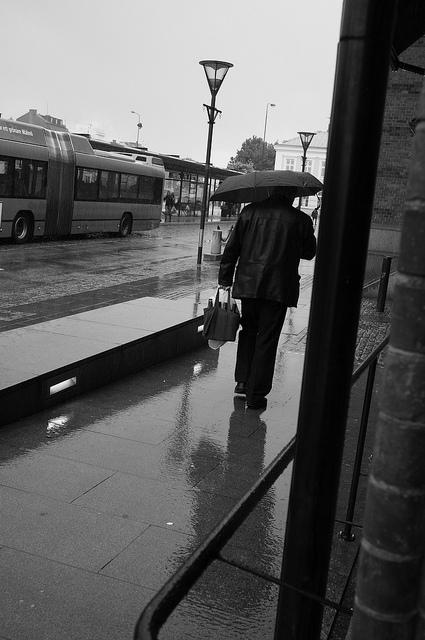How many people are in the street?
Quick response, please. 1. What is the weather like?
Quick response, please. Rainy. Could that be a bus stop across the street?
Keep it brief. Yes. 